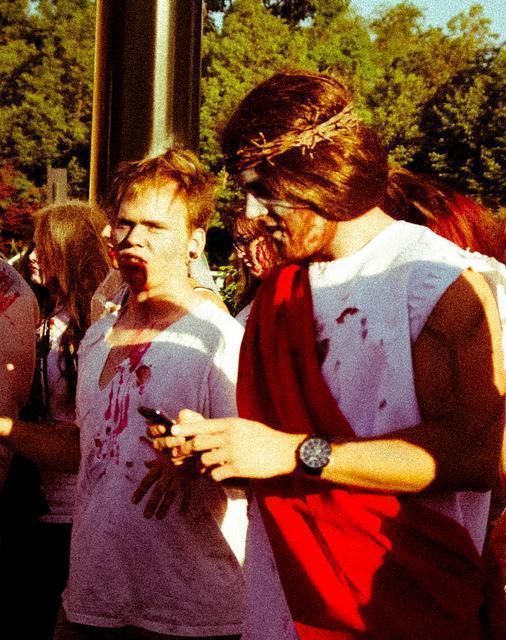What character does the man looking at his cell phone play?
Select the accurate response from the four choices given to answer the question.
Options: Mary poppins, jesus, sweeny todd, santa. Jesus. 